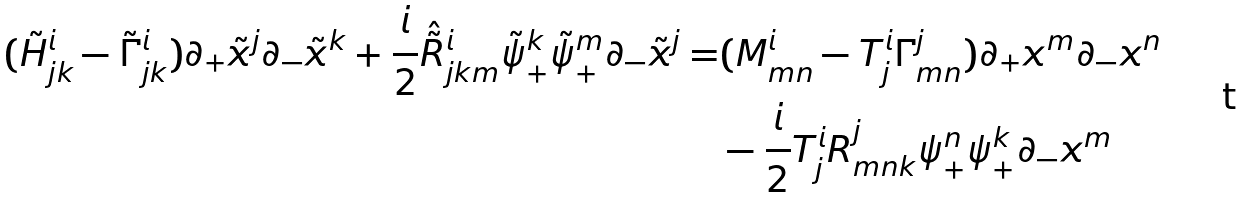<formula> <loc_0><loc_0><loc_500><loc_500>( \tilde { H } _ { j k } ^ { i } - \tilde { \Gamma } _ { j k } ^ { i } ) \partial _ { + } \tilde { x } ^ { j } \partial _ { - } \tilde { x } ^ { k } + \frac { i } { 2 } \hat { \tilde { R } } ^ { i } _ { j k m } \tilde { \psi } _ { + } ^ { k } \tilde { \psi } _ { + } ^ { m } \partial _ { - } \tilde { x } ^ { j } = & ( M _ { m n } ^ { i } - T _ { j } ^ { i } \Gamma _ { m n } ^ { j } ) \partial _ { + } x ^ { m } \partial _ { - } x ^ { n } \\ & - \frac { i } { 2 } T _ { j } ^ { i } R ^ { j } _ { m n k } \psi _ { + } ^ { n } \psi _ { + } ^ { k } \partial _ { - } x ^ { m }</formula> 